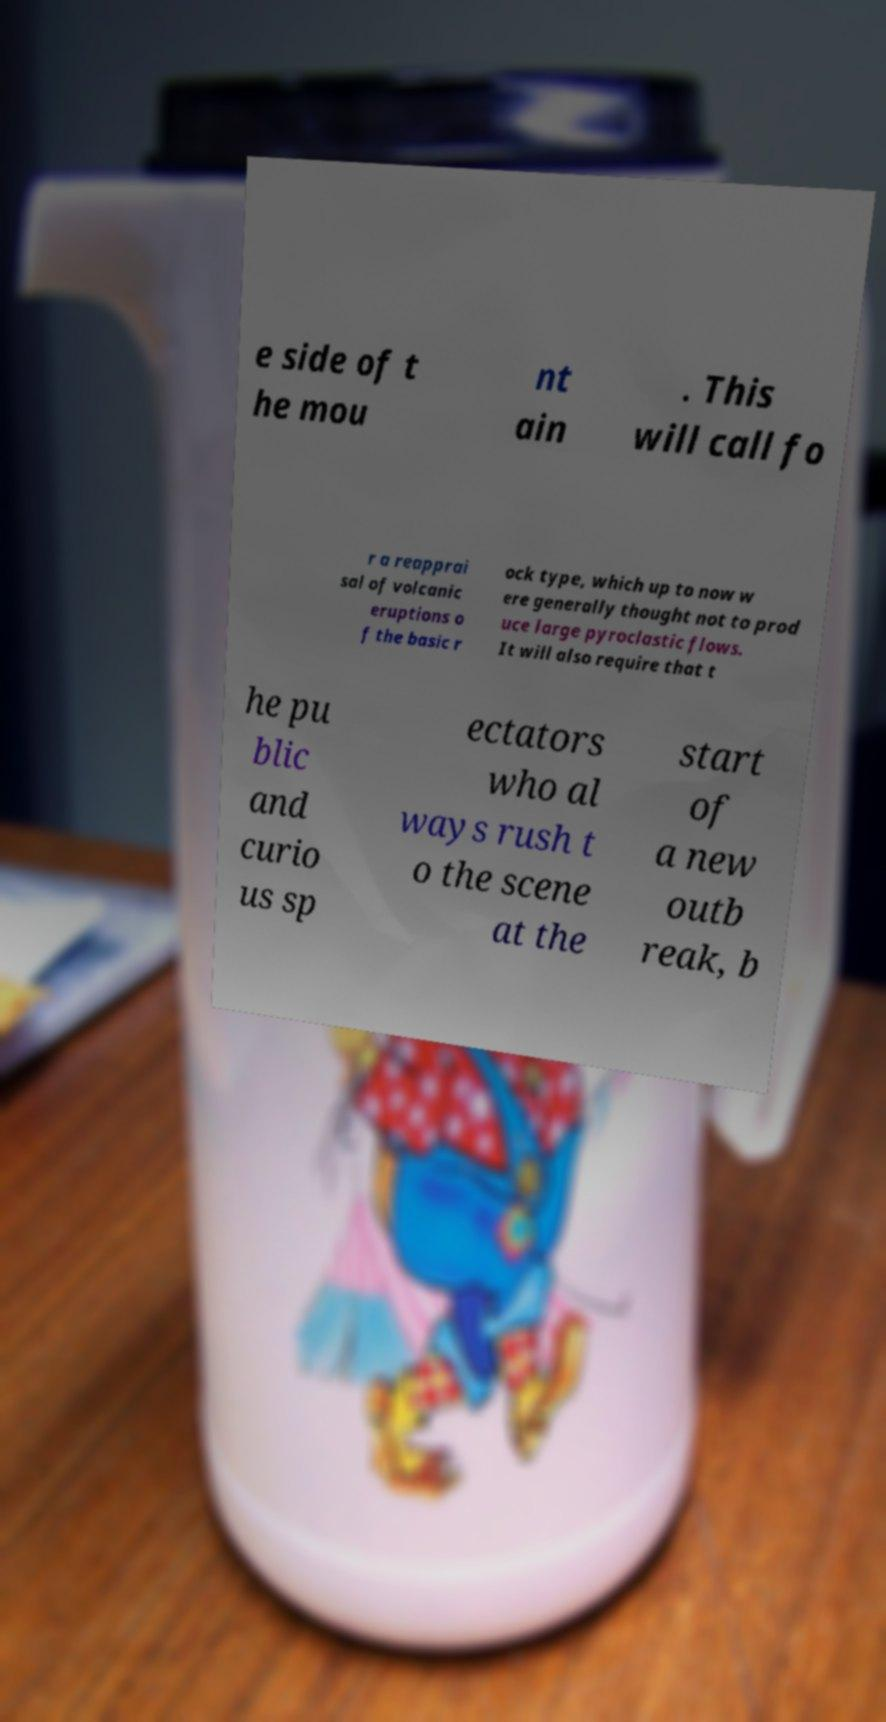Can you read and provide the text displayed in the image?This photo seems to have some interesting text. Can you extract and type it out for me? e side of t he mou nt ain . This will call fo r a reapprai sal of volcanic eruptions o f the basic r ock type, which up to now w ere generally thought not to prod uce large pyroclastic flows. It will also require that t he pu blic and curio us sp ectators who al ways rush t o the scene at the start of a new outb reak, b 